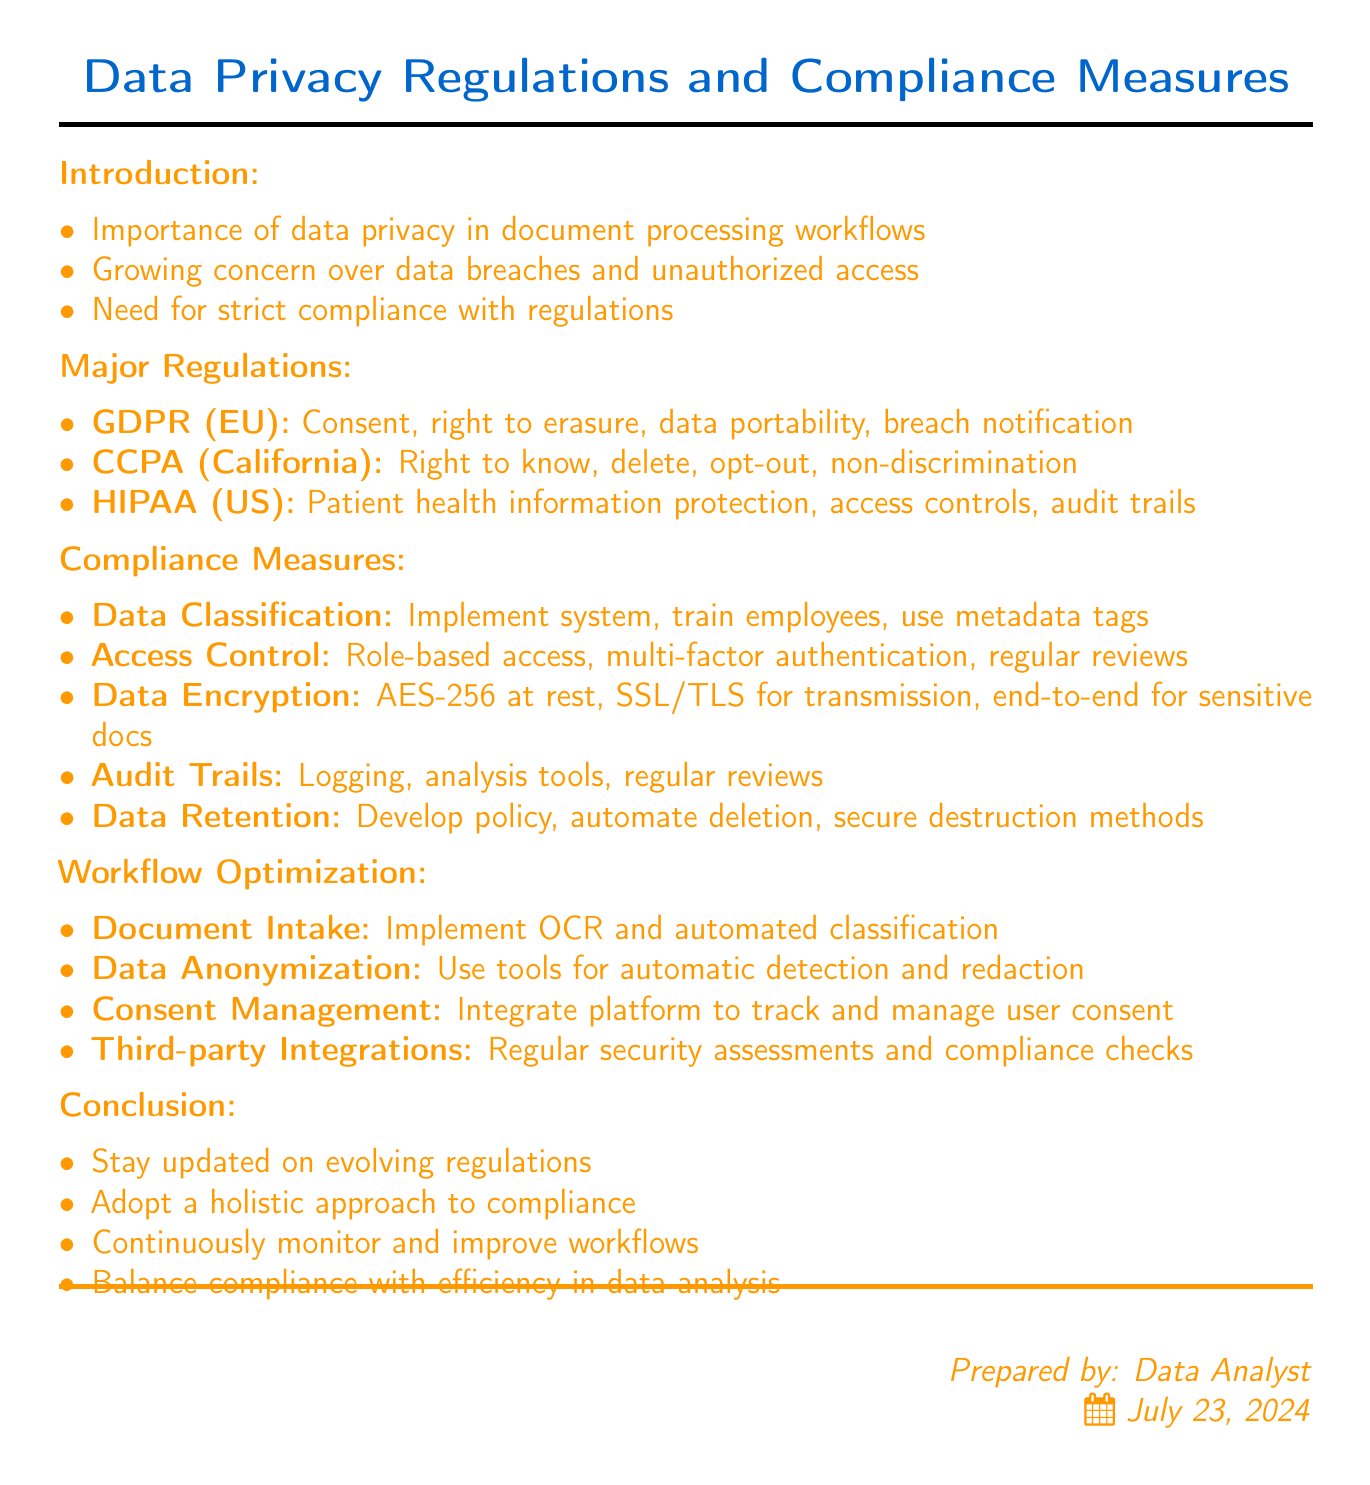What is the title of the memo? The title of the memo is provided at the top of the document.
Answer: Data Privacy Regulations and Compliance Measures for Document Handling Procedures What key requirement is part of GDPR? The memo lists key requirements under GDPR, including specific rights and obligations.
Answer: Right to erasure Which regulation pertains to California? The document specifies different regulations and their jurisdictions, highlighting those applicable to California.
Answer: CCPA What is one action under the category of Data Classification? The document outlines specific actions for each compliance measure, particularly under Data Classification.
Answer: Implement a data classification system How many major regulations are discussed in the memo? The memo explicitly mentions a count of the major regulations listed.
Answer: Three What recommendation is made for Document Intake? The memo provides recommendations to optimize workflows, particularly for Document Intake.
Answer: Implement OCR and automated classification Which encryption standard is recommended for data at rest? The document states specific encryption methods recommended for data protection.
Answer: AES-256 encryption What is a key takeaway from the conclusion? The conclusion summarizes important points regarding compliance and workflow improvements.
Answer: Importance of staying updated on evolving data privacy regulations What is the jurisdiction of HIPAA? The document specifies the jurisdiction associated with HIPAA.
Answer: United States 